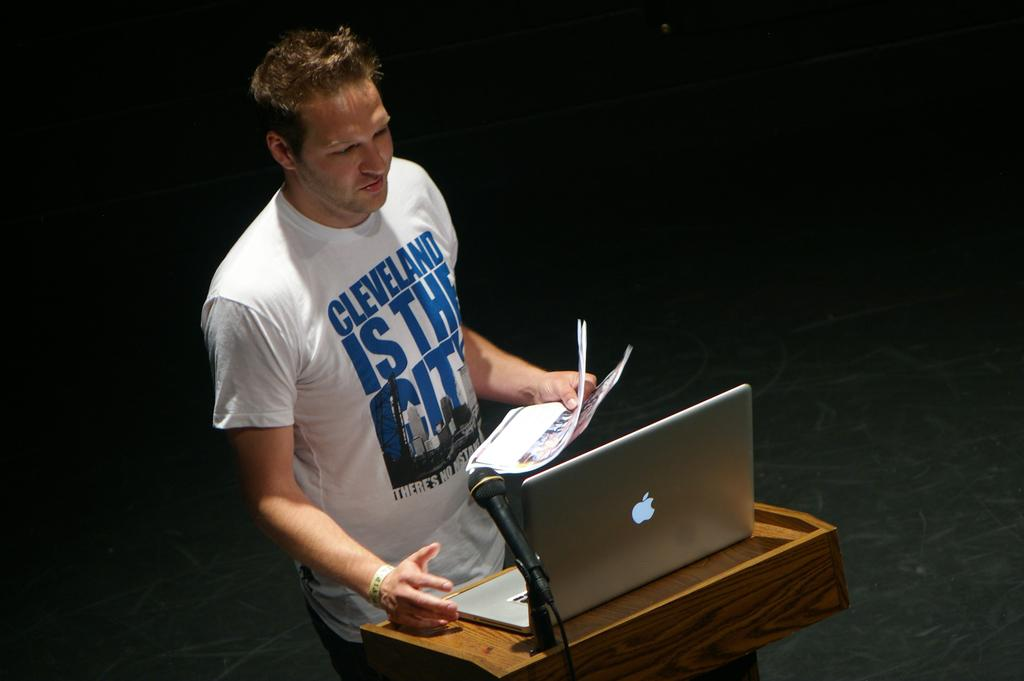<image>
Render a clear and concise summary of the photo. the man wearing the Cleveland is the city shirt is reading from an apple laptop 